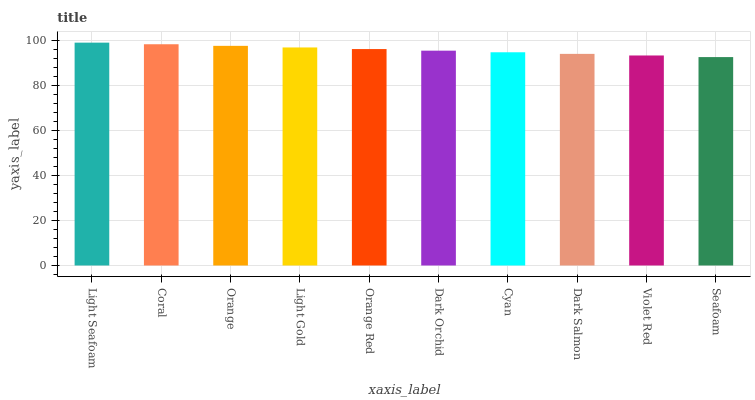Is Seafoam the minimum?
Answer yes or no. Yes. Is Light Seafoam the maximum?
Answer yes or no. Yes. Is Coral the minimum?
Answer yes or no. No. Is Coral the maximum?
Answer yes or no. No. Is Light Seafoam greater than Coral?
Answer yes or no. Yes. Is Coral less than Light Seafoam?
Answer yes or no. Yes. Is Coral greater than Light Seafoam?
Answer yes or no. No. Is Light Seafoam less than Coral?
Answer yes or no. No. Is Orange Red the high median?
Answer yes or no. Yes. Is Dark Orchid the low median?
Answer yes or no. Yes. Is Violet Red the high median?
Answer yes or no. No. Is Light Seafoam the low median?
Answer yes or no. No. 